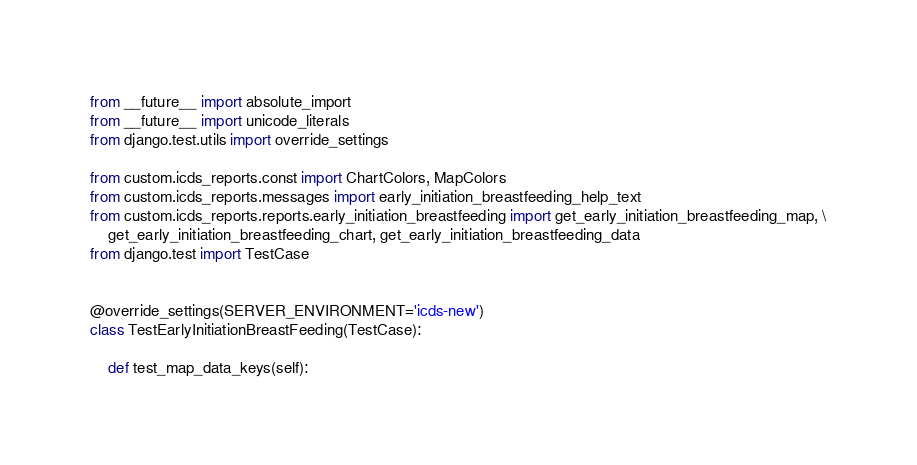<code> <loc_0><loc_0><loc_500><loc_500><_Python_>from __future__ import absolute_import
from __future__ import unicode_literals
from django.test.utils import override_settings

from custom.icds_reports.const import ChartColors, MapColors
from custom.icds_reports.messages import early_initiation_breastfeeding_help_text
from custom.icds_reports.reports.early_initiation_breastfeeding import get_early_initiation_breastfeeding_map, \
    get_early_initiation_breastfeeding_chart, get_early_initiation_breastfeeding_data
from django.test import TestCase


@override_settings(SERVER_ENVIRONMENT='icds-new')
class TestEarlyInitiationBreastFeeding(TestCase):

    def test_map_data_keys(self):</code> 